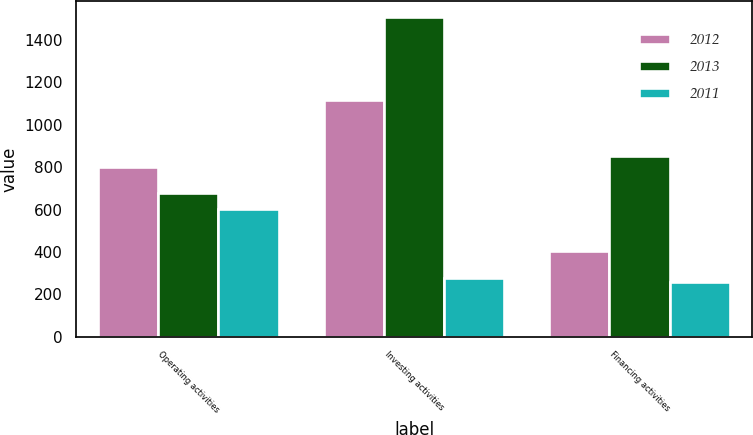<chart> <loc_0><loc_0><loc_500><loc_500><stacked_bar_chart><ecel><fcel>Operating activities<fcel>Investing activities<fcel>Financing activities<nl><fcel>2012<fcel>802.6<fcel>1115.9<fcel>403.6<nl><fcel>2013<fcel>677.9<fcel>1505.6<fcel>853.9<nl><fcel>2011<fcel>601.6<fcel>275.7<fcel>256.7<nl></chart> 